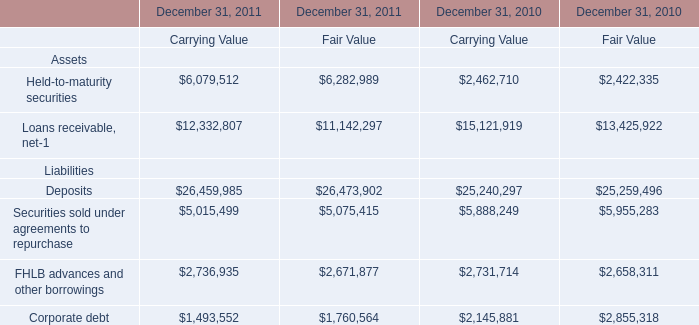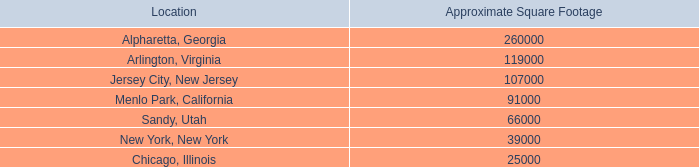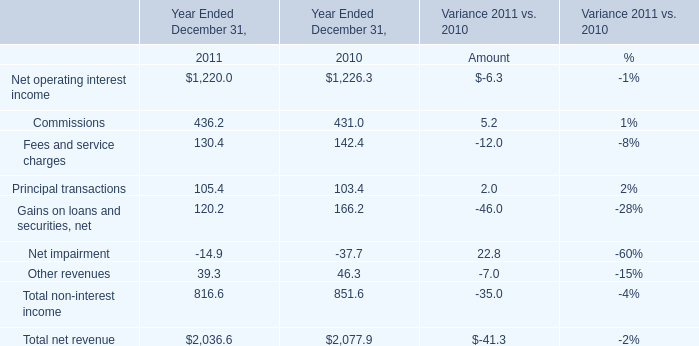What is the total amount of Corporate debt Liabilities of December 31, 2011 Carrying Value, Menlo Park, California of Approximate Square Footage, and FHLB advances and other borrowings Liabilities of December 31, 2011 Fair Value ? 
Computations: ((1493552.0 + 91000.0) + 2671877.0)
Answer: 4256429.0. 